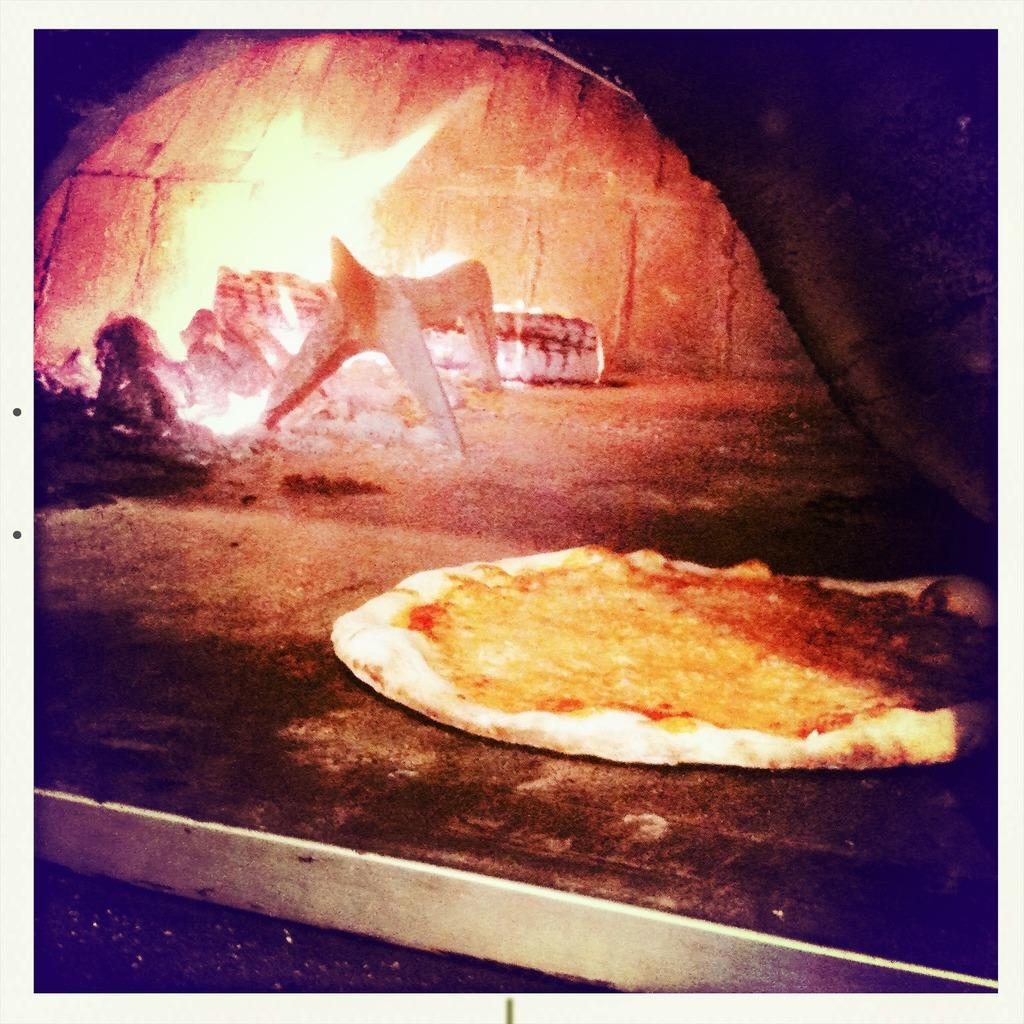What type of appliance is present in the image? There is an oven in the image. What is inside the oven in the image? There is food placed in the oven. What can be seen in the image that might be related to the oven? Fire is visible in the image, likely related to the oven. What type of summer activity is depicted in the image? There is no summer activity depicted in the image; it features an oven with food inside. What might the writer of the image be trying to convey about the aftermath of a situation? The image does not depict any situation or aftermath; it simply shows an oven with food inside. 